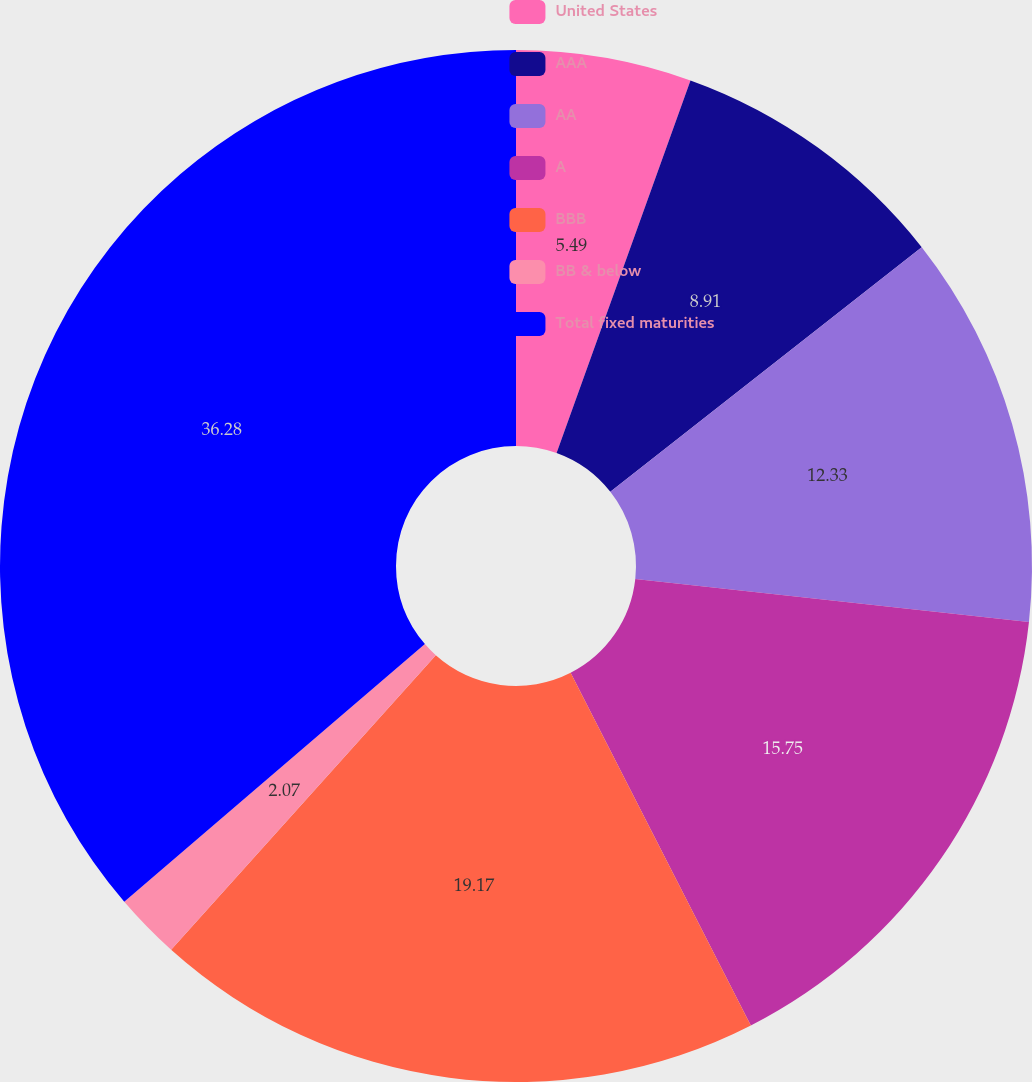Convert chart to OTSL. <chart><loc_0><loc_0><loc_500><loc_500><pie_chart><fcel>United States<fcel>AAA<fcel>AA<fcel>A<fcel>BBB<fcel>BB & below<fcel>Total fixed maturities<nl><fcel>5.49%<fcel>8.91%<fcel>12.33%<fcel>15.75%<fcel>19.17%<fcel>2.07%<fcel>36.28%<nl></chart> 